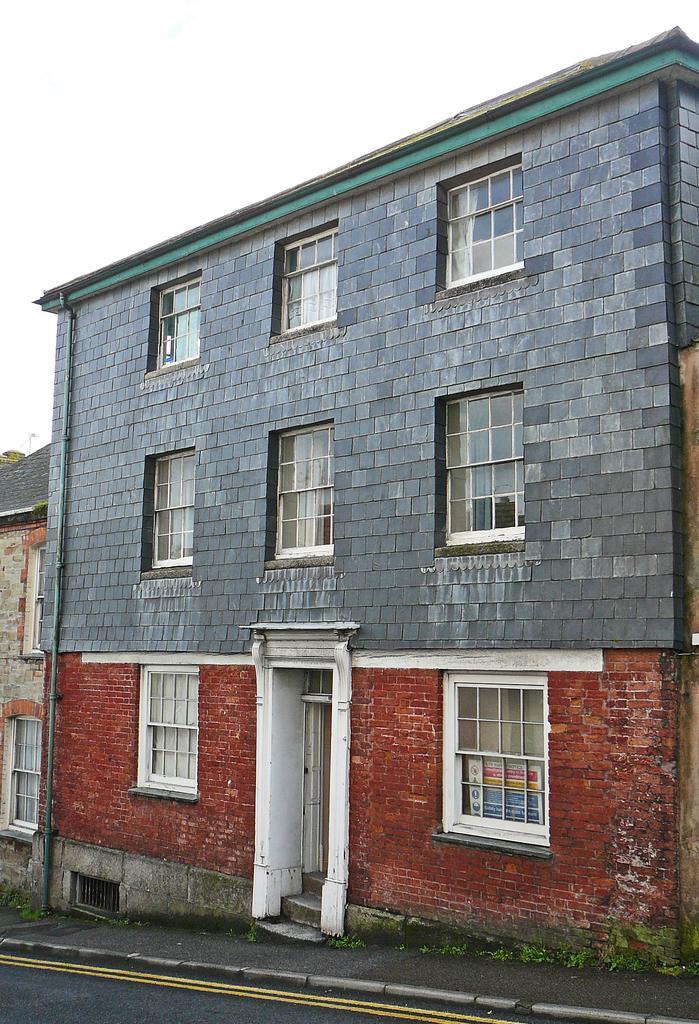Please provide a concise description of this image. There is a building in the center of the image and a house on the left side, there are plants and a road at the bottom side, there is the sky in the background. 